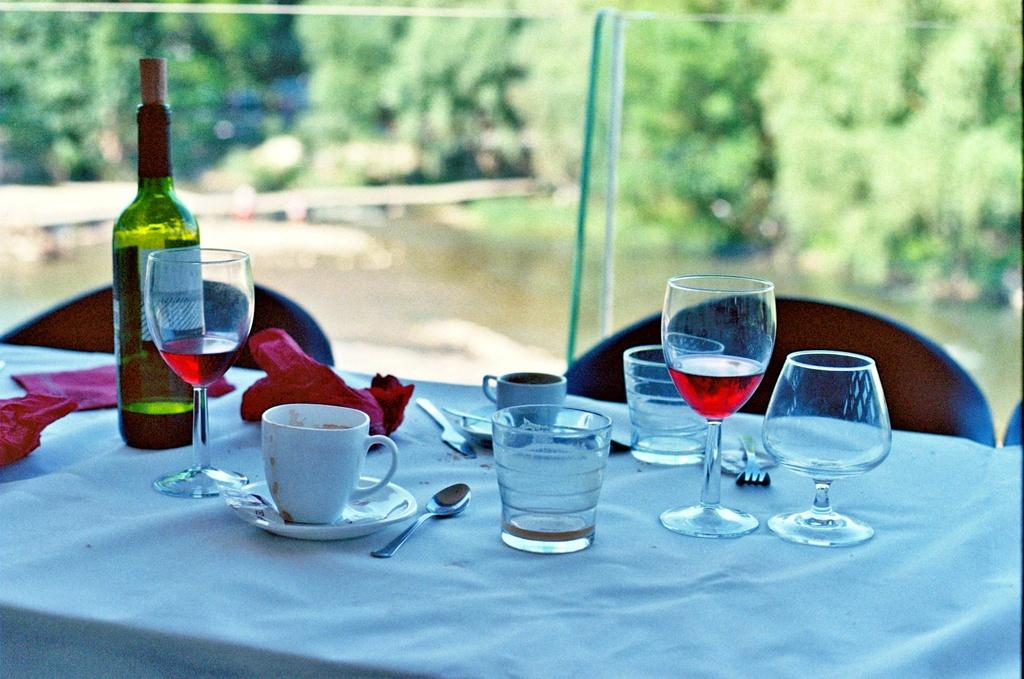What type of glasses are present in the image? There are wine glasses and tea cups in the image. What beverage might be associated with the wine glasses? Wine might be associated with the wine glasses, as there is also a wine bottle in the image. Where are the glasses and bottle located? They are on a table in the image. What type of furniture is present in the image? There are chairs in the image. What can be seen in the background of the scene? Trees are visible around the scene. What type of class is being taught in the image? There is no class or teaching activity depicted in the image; it features wine glasses, tea cups, a wine bottle, a table, chairs, and trees in the background. 